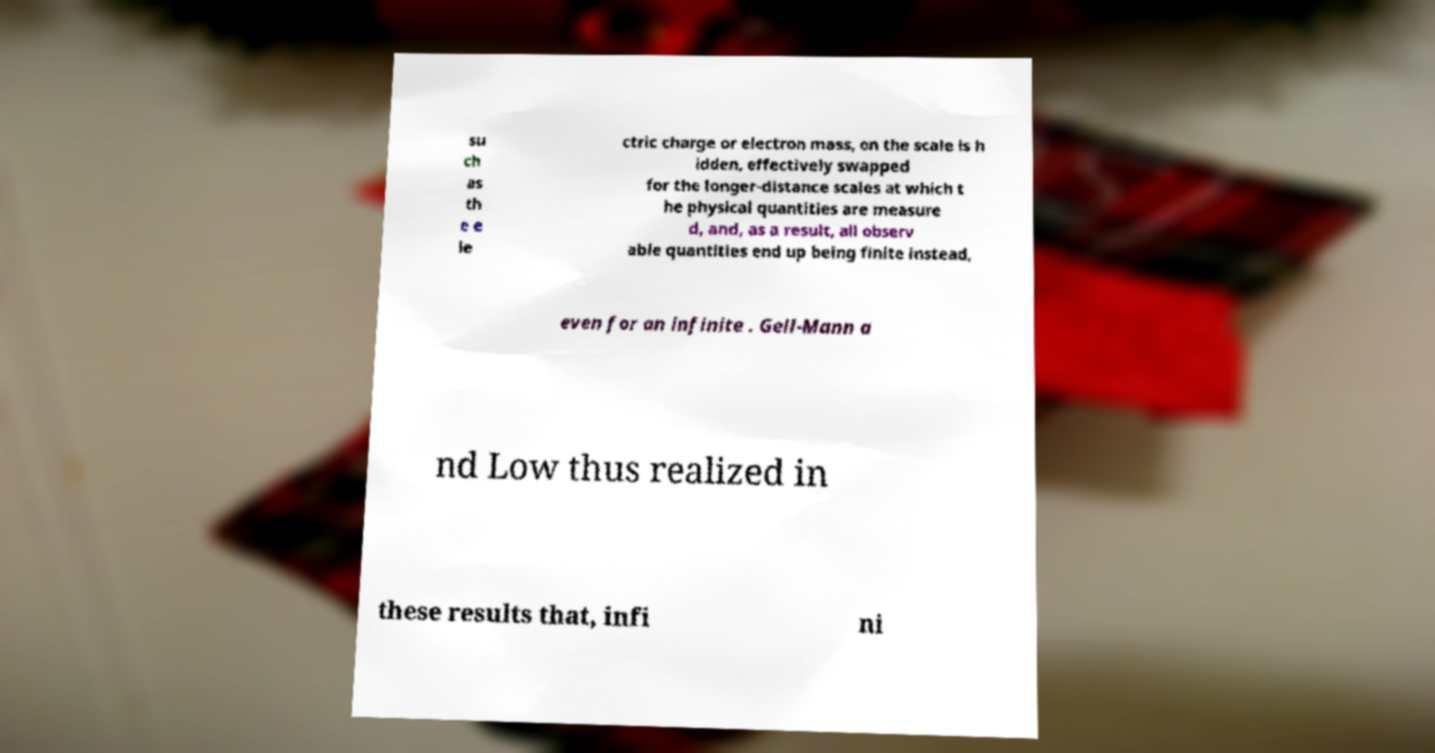Please read and relay the text visible in this image. What does it say? su ch as th e e le ctric charge or electron mass, on the scale is h idden, effectively swapped for the longer-distance scales at which t he physical quantities are measure d, and, as a result, all observ able quantities end up being finite instead, even for an infinite . Gell-Mann a nd Low thus realized in these results that, infi ni 